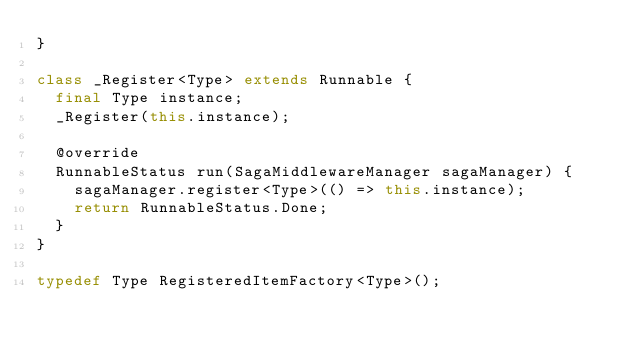Convert code to text. <code><loc_0><loc_0><loc_500><loc_500><_Dart_>}

class _Register<Type> extends Runnable {
  final Type instance;
  _Register(this.instance);

  @override
  RunnableStatus run(SagaMiddlewareManager sagaManager) {
    sagaManager.register<Type>(() => this.instance);
    return RunnableStatus.Done;
  }
}

typedef Type RegisteredItemFactory<Type>();
</code> 